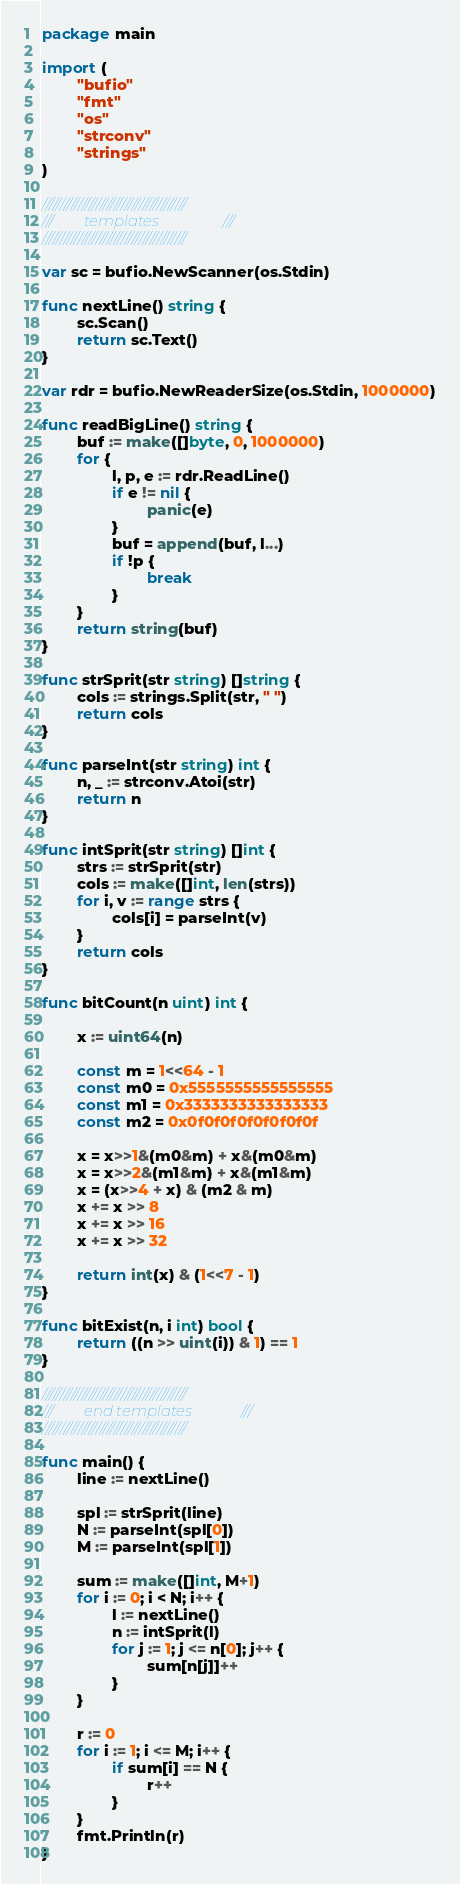<code> <loc_0><loc_0><loc_500><loc_500><_Go_>package main

import (
        "bufio"
        "fmt"
        "os"
        "strconv"
        "strings"
)

////////////////////////////////////////
///        templates                 ///
////////////////////////////////////////

var sc = bufio.NewScanner(os.Stdin)

func nextLine() string {
        sc.Scan()
        return sc.Text()
}

var rdr = bufio.NewReaderSize(os.Stdin, 1000000)

func readBigLine() string {
        buf := make([]byte, 0, 1000000)
        for {
                l, p, e := rdr.ReadLine()
                if e != nil {
                        panic(e)
                }
                buf = append(buf, l...)
                if !p {
                        break
                }
        }
        return string(buf)
}

func strSprit(str string) []string {
        cols := strings.Split(str, " ")
        return cols
}

func parseInt(str string) int {
        n, _ := strconv.Atoi(str)
        return n
}

func intSprit(str string) []int {
        strs := strSprit(str)
        cols := make([]int, len(strs))
        for i, v := range strs {
                cols[i] = parseInt(v)
        }
        return cols
}

func bitCount(n uint) int {

        x := uint64(n)

        const m = 1<<64 - 1
        const m0 = 0x5555555555555555
        const m1 = 0x3333333333333333
        const m2 = 0x0f0f0f0f0f0f0f0f

        x = x>>1&(m0&m) + x&(m0&m)
        x = x>>2&(m1&m) + x&(m1&m)
        x = (x>>4 + x) & (m2 & m)
        x += x >> 8
        x += x >> 16
        x += x >> 32

        return int(x) & (1<<7 - 1)
}

func bitExist(n, i int) bool {
        return ((n >> uint(i)) & 1) == 1
}

////////////////////////////////////////
///        end templates             ///
////////////////////////////////////////

func main() {
        line := nextLine()

        spl := strSprit(line)
        N := parseInt(spl[0])
        M := parseInt(spl[1])

        sum := make([]int, M+1)
        for i := 0; i < N; i++ {
                l := nextLine()
                n := intSprit(l)
                for j := 1; j <= n[0]; j++ {
                        sum[n[j]]++
                }
        }

        r := 0
        for i := 1; i <= M; i++ {
                if sum[i] == N {
                        r++
                }
        }
        fmt.Println(r)
}
</code> 